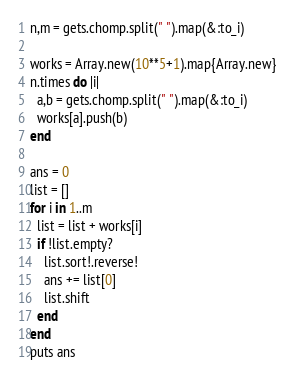<code> <loc_0><loc_0><loc_500><loc_500><_Ruby_>n,m = gets.chomp.split(" ").map(&:to_i)

works = Array.new(10**5+1).map{Array.new}
n.times do |i|
  a,b = gets.chomp.split(" ").map(&:to_i)
  works[a].push(b)
end

ans = 0
list = []
for i in 1..m
  list = list + works[i]
  if !list.empty?
    list.sort!.reverse!
    ans += list[0]
    list.shift
  end
end
puts ans</code> 